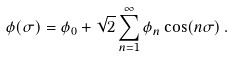Convert formula to latex. <formula><loc_0><loc_0><loc_500><loc_500>\phi ( \sigma ) = \phi _ { 0 } + { \sqrt { 2 } } \sum _ { n = 1 } ^ { \infty } \phi _ { n } \cos ( n \sigma ) \, .</formula> 